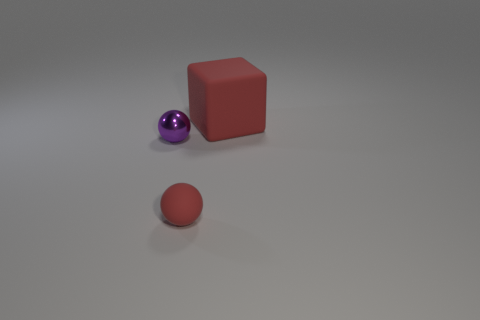Does the shiny thing have the same shape as the large red object?
Keep it short and to the point. No. What is the tiny ball that is in front of the purple metal object made of?
Your answer should be compact. Rubber. What color is the matte block?
Provide a succinct answer. Red. There is a red thing on the left side of the big red matte thing; is it the same size as the metallic thing that is on the left side of the large red matte object?
Give a very brief answer. Yes. What size is the object that is both in front of the block and right of the purple metal ball?
Keep it short and to the point. Small. What color is the metal object that is the same shape as the tiny matte object?
Offer a very short reply. Purple. Is the number of red things behind the small matte object greater than the number of tiny metal spheres on the left side of the purple metallic object?
Your answer should be very brief. Yes. How many other objects are there of the same shape as the shiny object?
Your answer should be compact. 1. Is there a metal sphere right of the red matte thing that is left of the large red object?
Your response must be concise. No. How many tiny purple metallic things are there?
Your answer should be compact. 1. 